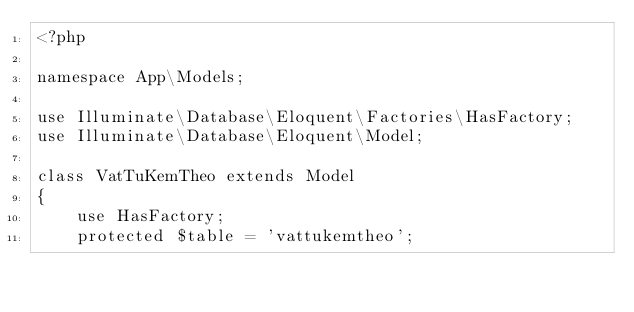Convert code to text. <code><loc_0><loc_0><loc_500><loc_500><_PHP_><?php

namespace App\Models;

use Illuminate\Database\Eloquent\Factories\HasFactory;
use Illuminate\Database\Eloquent\Model;

class VatTuKemTheo extends Model
{
    use HasFactory;
    protected $table = 'vattukemtheo';</code> 